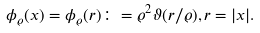<formula> <loc_0><loc_0><loc_500><loc_500>\phi _ { \varrho } ( x ) = \phi _ { \varrho } ( r ) \colon = \varrho ^ { 2 } \vartheta ( r / \varrho ) , r = | x | .</formula> 